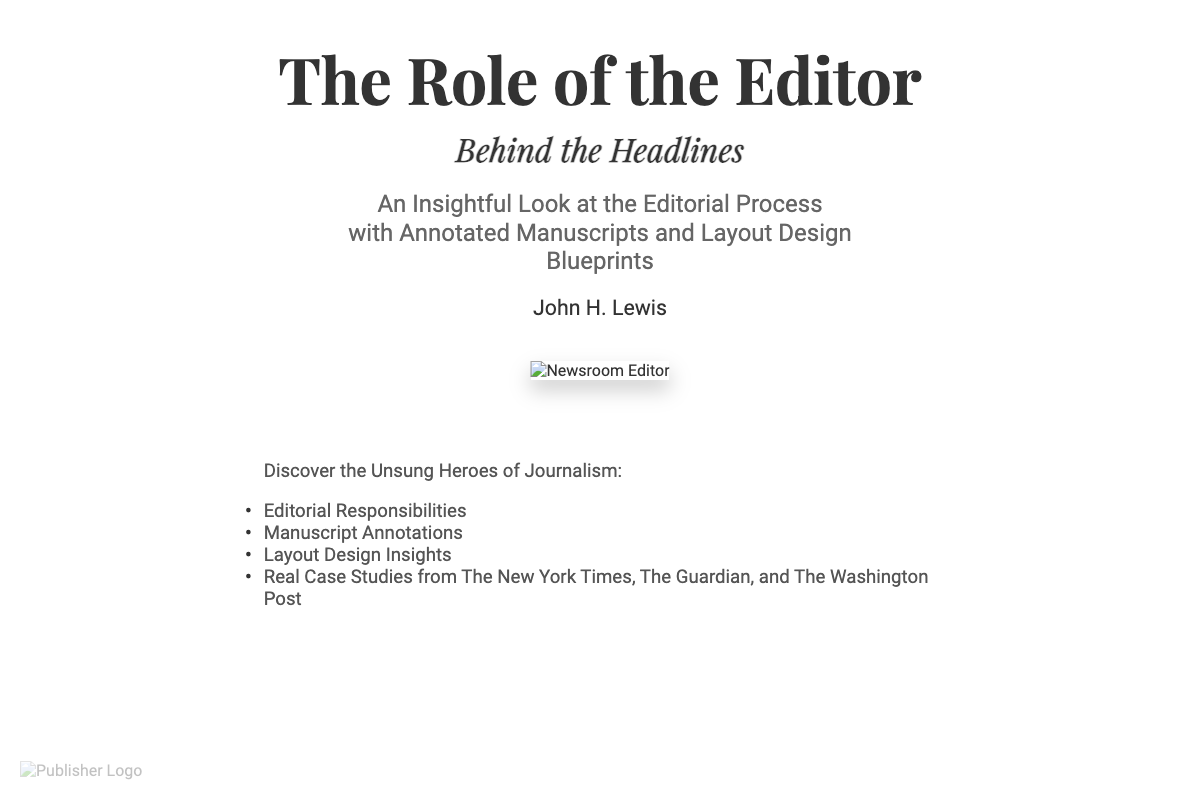What is the title of the book? The title of the book is prominently displayed at the top of the cover.
Answer: The Role of the Editor Who is the author of the book? The author's name appears below the subtitle on the book cover.
Answer: John H. Lewis What is the subtitle of the book? The subtitle is included beneath the main title, elaborating on the book's focus.
Answer: Behind the Headlines What type of design elements are included in the book? The book mentions specific elements that enhance the reading experience, mentioned in the features section.
Answer: Annotated Manuscripts and Layout Design Blueprints List one of the features of the book. The features section outlines several unique aspects of the editorial process discussed in the book.
Answer: Editorial Responsibilities Which organizations are referenced for real case studies in the book? The features section includes names of prestigious publications providing practical examples in the book.
Answer: The New York Times, The Guardian, and The Washington Post What font is used for the book's title? The style used for the title is highlighted with specific details in the CSS section of the document's code.
Answer: Playfair Display What color is used for the body text? The book cover specifies the color of the main text in its CSS styling, contributing to the overall aesthetic.
Answer: #333333 What is the main theme of the book? The theme is derived from the title and subtitle displayed on the cover, reflecting its focus.
Answer: The Editorial Process 